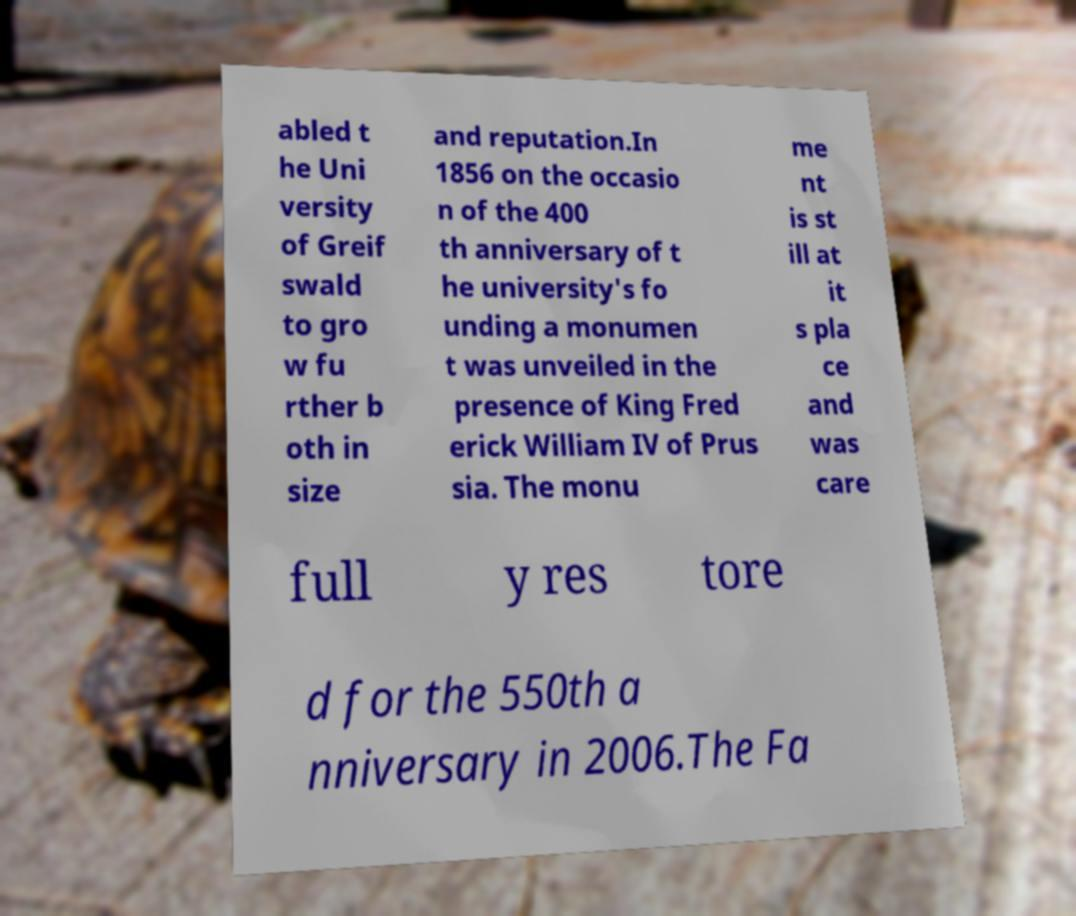Can you accurately transcribe the text from the provided image for me? abled t he Uni versity of Greif swald to gro w fu rther b oth in size and reputation.In 1856 on the occasio n of the 400 th anniversary of t he university's fo unding a monumen t was unveiled in the presence of King Fred erick William IV of Prus sia. The monu me nt is st ill at it s pla ce and was care full y res tore d for the 550th a nniversary in 2006.The Fa 